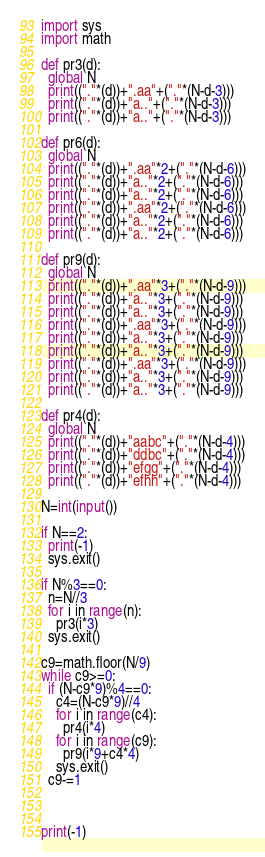Convert code to text. <code><loc_0><loc_0><loc_500><loc_500><_Python_>import sys
import math

def pr3(d):
  global N
  print(("."*(d))+".aa"+("."*(N-d-3)))
  print(("."*(d))+"a.."+("."*(N-d-3)))
  print(("."*(d))+"a.."+("."*(N-d-3)))
  
def pr6(d):
  global N
  print(("."*(d))+".aa"*2+("."*(N-d-6)))
  print(("."*(d))+"a.."*2+("."*(N-d-6)))
  print(("."*(d))+"a.."*2+("."*(N-d-6)))
  print(("."*(d))+".aa"*2+("."*(N-d-6)))
  print(("."*(d))+"a.."*2+("."*(N-d-6)))
  print(("."*(d))+"a.."*2+("."*(N-d-6)))

def pr9(d):
  global N
  print(("."*(d))+".aa"*3+("."*(N-d-9)))
  print(("."*(d))+"a.."*3+("."*(N-d-9)))
  print(("."*(d))+"a.."*3+("."*(N-d-9)))
  print(("."*(d))+".aa"*3+("."*(N-d-9)))
  print(("."*(d))+"a.."*3+("."*(N-d-9)))
  print(("."*(d))+"a.."*3+("."*(N-d-9)))
  print(("."*(d))+".aa"*3+("."*(N-d-9)))
  print(("."*(d))+"a.."*3+("."*(N-d-9)))
  print(("."*(d))+"a.."*3+("."*(N-d-9)))

def pr4(d):
  global N
  print(("."*(d))+"aabc"+("."*(N-d-4)))
  print(("."*(d))+"ddbc"+("."*(N-d-4)))
  print(("."*(d))+"efgg"+("."*(N-d-4)))
  print(("."*(d))+"efhh"+("."*(N-d-4)))
	
N=int(input())

if N==2:
  print(-1)
  sys.exit()

if N%3==0:
  n=N//3
  for i in range(n):
    pr3(i*3)
  sys.exit()

c9=math.floor(N/9)
while c9>=0:
  if (N-c9*9)%4==0:
    c4=(N-c9*9)//4
    for i in range(c4):
      pr4(i*4)
    for i in range(c9):
      pr9(i*9+c4*4)
    sys.exit()
  c9-=1



print(-1)</code> 